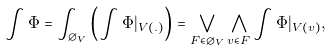Convert formula to latex. <formula><loc_0><loc_0><loc_500><loc_500>\int \Phi = \int _ { \varnothing _ { V } } \left ( \int \Phi | _ { V ( . ) } \right ) = \bigvee _ { F \in \varnothing _ { V } } \bigwedge _ { v \in F } \int \Phi | _ { V ( v ) } ,</formula> 